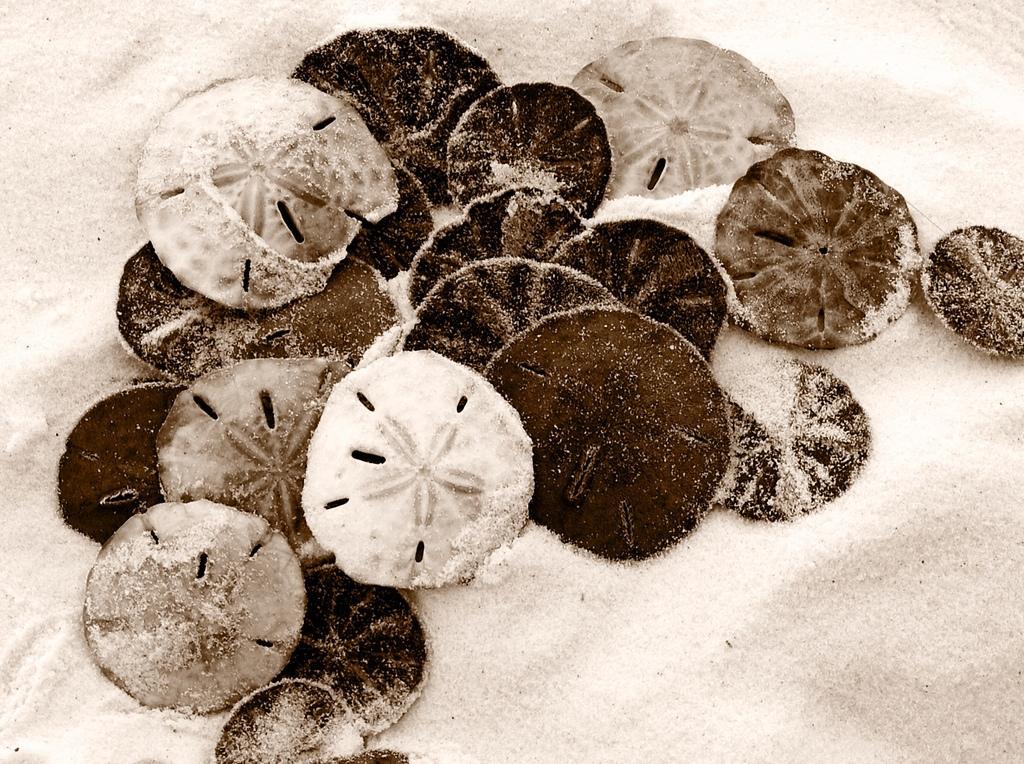Can you describe this image briefly? In the center of the image we can see sand dollar are present. In the background of the image soil is there. 